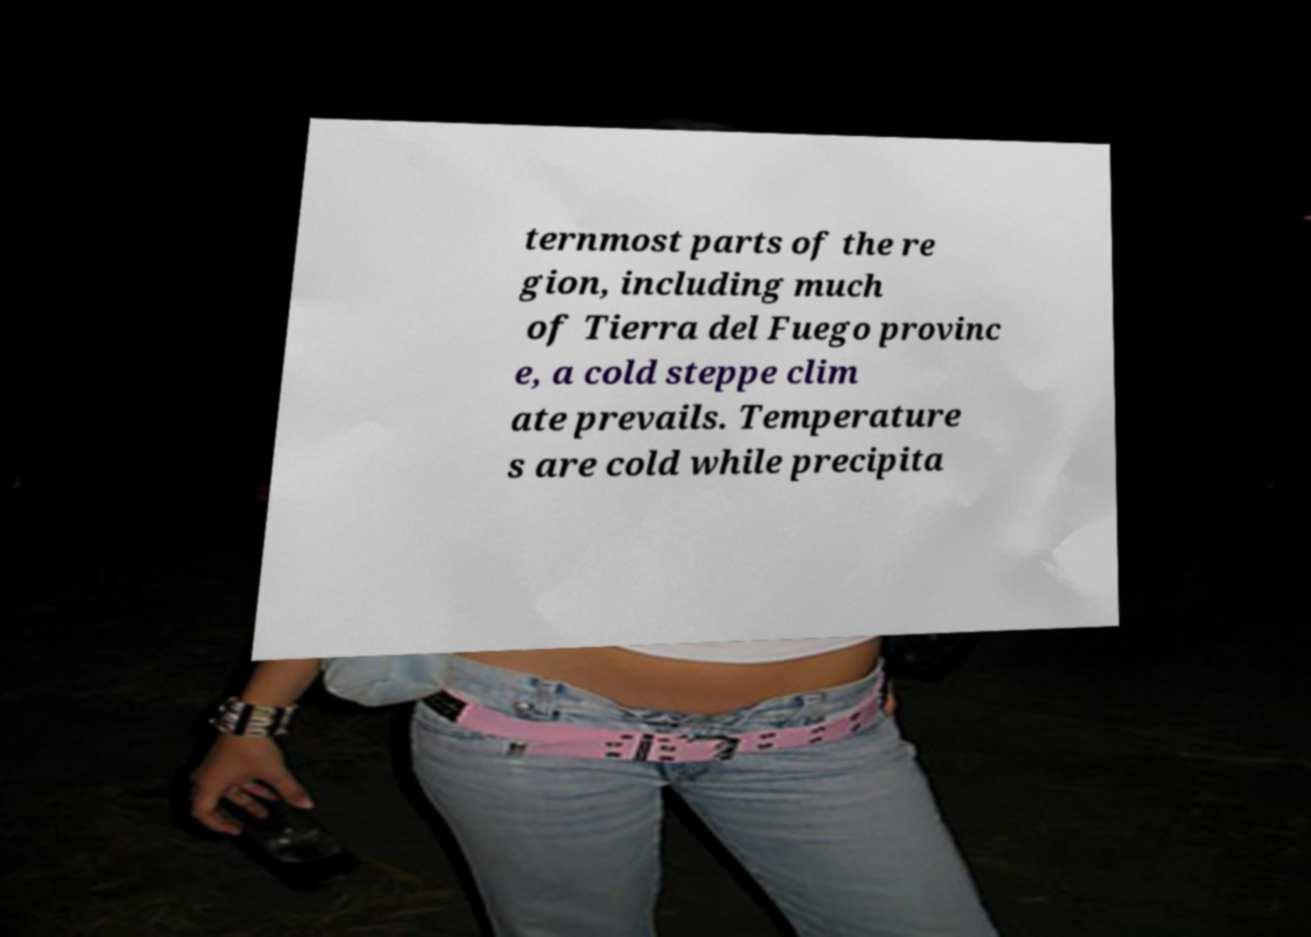There's text embedded in this image that I need extracted. Can you transcribe it verbatim? ternmost parts of the re gion, including much of Tierra del Fuego provinc e, a cold steppe clim ate prevails. Temperature s are cold while precipita 